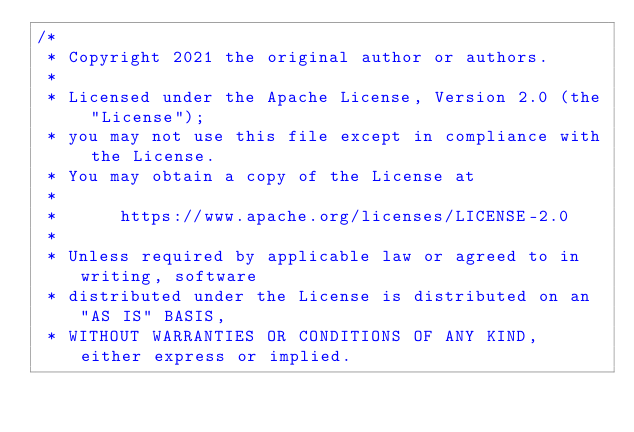Convert code to text. <code><loc_0><loc_0><loc_500><loc_500><_Java_>/*
 * Copyright 2021 the original author or authors.
 *
 * Licensed under the Apache License, Version 2.0 (the "License");
 * you may not use this file except in compliance with the License.
 * You may obtain a copy of the License at
 *
 *      https://www.apache.org/licenses/LICENSE-2.0
 *
 * Unless required by applicable law or agreed to in writing, software
 * distributed under the License is distributed on an "AS IS" BASIS,
 * WITHOUT WARRANTIES OR CONDITIONS OF ANY KIND, either express or implied.</code> 